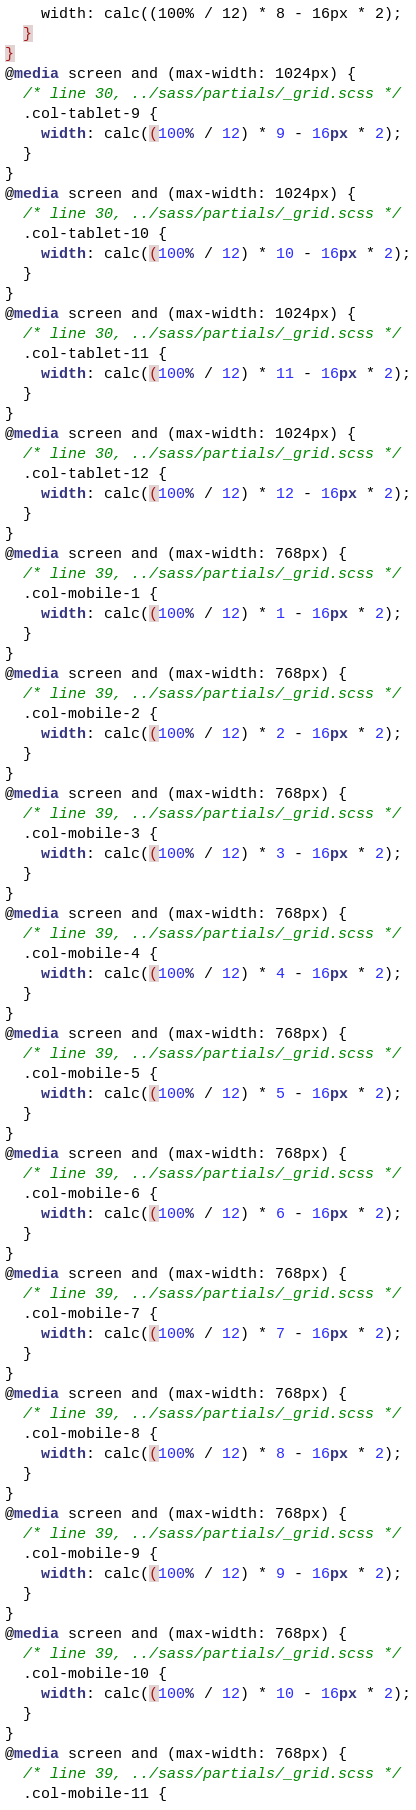Convert code to text. <code><loc_0><loc_0><loc_500><loc_500><_CSS_>    width: calc((100% / 12) * 8 - 16px * 2);
  }
}
@media screen and (max-width: 1024px) {
  /* line 30, ../sass/partials/_grid.scss */
  .col-tablet-9 {
    width: calc((100% / 12) * 9 - 16px * 2);
  }
}
@media screen and (max-width: 1024px) {
  /* line 30, ../sass/partials/_grid.scss */
  .col-tablet-10 {
    width: calc((100% / 12) * 10 - 16px * 2);
  }
}
@media screen and (max-width: 1024px) {
  /* line 30, ../sass/partials/_grid.scss */
  .col-tablet-11 {
    width: calc((100% / 12) * 11 - 16px * 2);
  }
}
@media screen and (max-width: 1024px) {
  /* line 30, ../sass/partials/_grid.scss */
  .col-tablet-12 {
    width: calc((100% / 12) * 12 - 16px * 2);
  }
}
@media screen and (max-width: 768px) {
  /* line 39, ../sass/partials/_grid.scss */
  .col-mobile-1 {
    width: calc((100% / 12) * 1 - 16px * 2);
  }
}
@media screen and (max-width: 768px) {
  /* line 39, ../sass/partials/_grid.scss */
  .col-mobile-2 {
    width: calc((100% / 12) * 2 - 16px * 2);
  }
}
@media screen and (max-width: 768px) {
  /* line 39, ../sass/partials/_grid.scss */
  .col-mobile-3 {
    width: calc((100% / 12) * 3 - 16px * 2);
  }
}
@media screen and (max-width: 768px) {
  /* line 39, ../sass/partials/_grid.scss */
  .col-mobile-4 {
    width: calc((100% / 12) * 4 - 16px * 2);
  }
}
@media screen and (max-width: 768px) {
  /* line 39, ../sass/partials/_grid.scss */
  .col-mobile-5 {
    width: calc((100% / 12) * 5 - 16px * 2);
  }
}
@media screen and (max-width: 768px) {
  /* line 39, ../sass/partials/_grid.scss */
  .col-mobile-6 {
    width: calc((100% / 12) * 6 - 16px * 2);
  }
}
@media screen and (max-width: 768px) {
  /* line 39, ../sass/partials/_grid.scss */
  .col-mobile-7 {
    width: calc((100% / 12) * 7 - 16px * 2);
  }
}
@media screen and (max-width: 768px) {
  /* line 39, ../sass/partials/_grid.scss */
  .col-mobile-8 {
    width: calc((100% / 12) * 8 - 16px * 2);
  }
}
@media screen and (max-width: 768px) {
  /* line 39, ../sass/partials/_grid.scss */
  .col-mobile-9 {
    width: calc((100% / 12) * 9 - 16px * 2);
  }
}
@media screen and (max-width: 768px) {
  /* line 39, ../sass/partials/_grid.scss */
  .col-mobile-10 {
    width: calc((100% / 12) * 10 - 16px * 2);
  }
}
@media screen and (max-width: 768px) {
  /* line 39, ../sass/partials/_grid.scss */
  .col-mobile-11 {</code> 